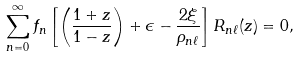Convert formula to latex. <formula><loc_0><loc_0><loc_500><loc_500>\sum _ { n = 0 } ^ { \infty } f _ { n } \left [ \left ( \frac { 1 + z } { 1 - z } \right ) + \epsilon - \frac { 2 \xi } { \rho _ { n \ell } } \right ] R _ { n \ell } ( z ) = 0 ,</formula> 